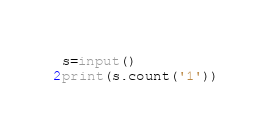Convert code to text. <code><loc_0><loc_0><loc_500><loc_500><_Python_>s=input()
print(s.count('1'))</code> 